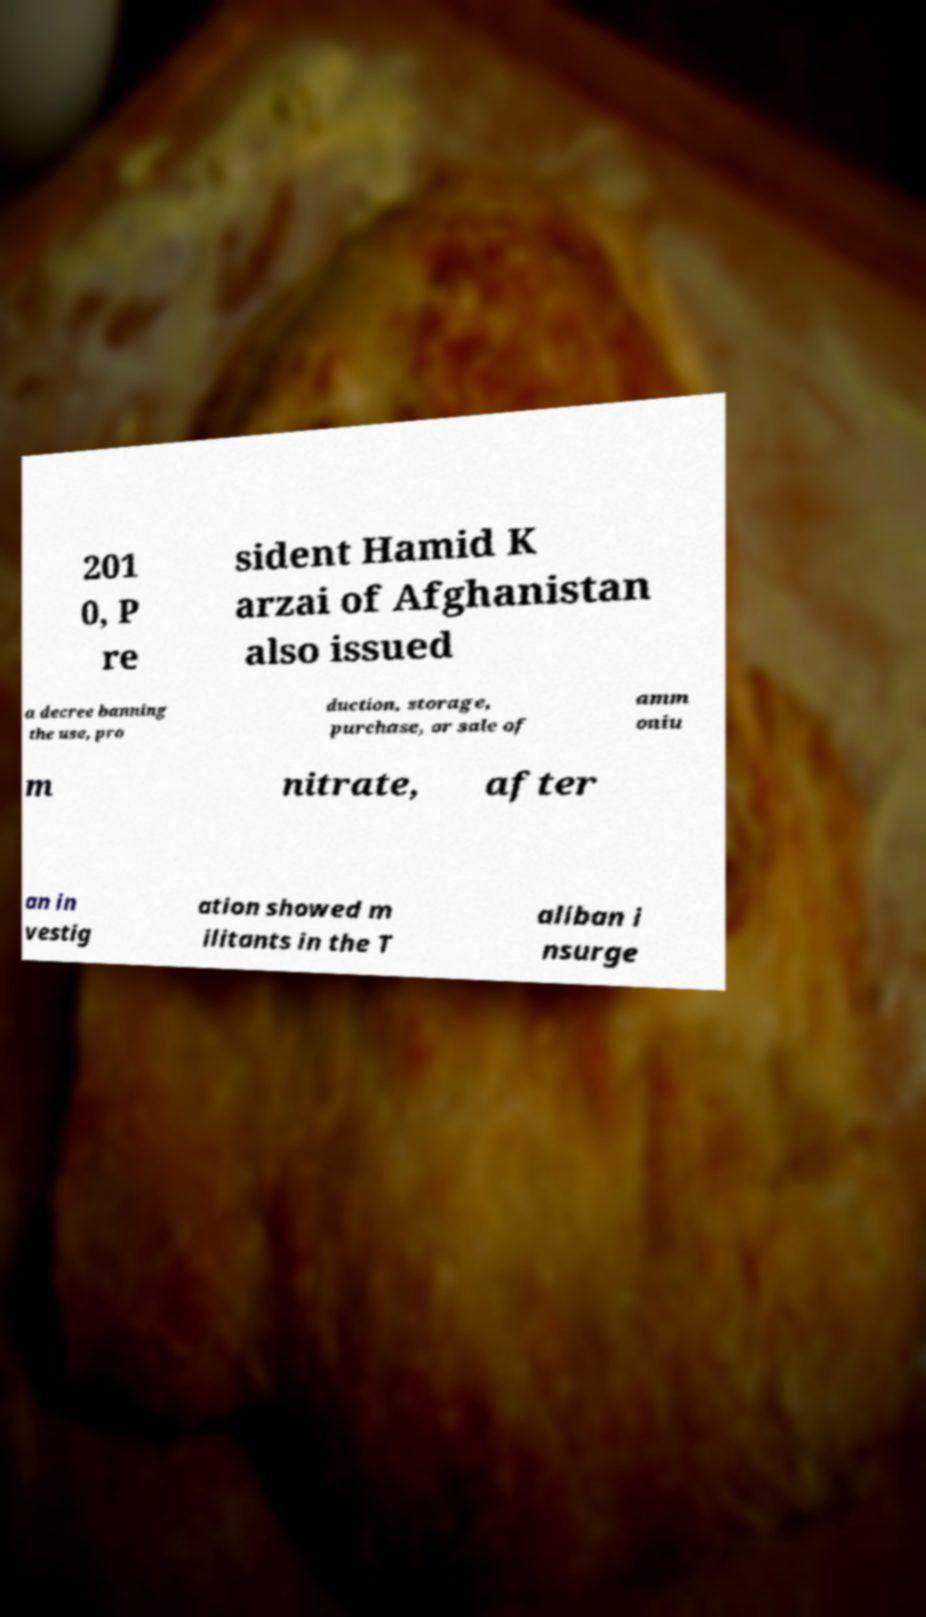There's text embedded in this image that I need extracted. Can you transcribe it verbatim? 201 0, P re sident Hamid K arzai of Afghanistan also issued a decree banning the use, pro duction, storage, purchase, or sale of amm oniu m nitrate, after an in vestig ation showed m ilitants in the T aliban i nsurge 